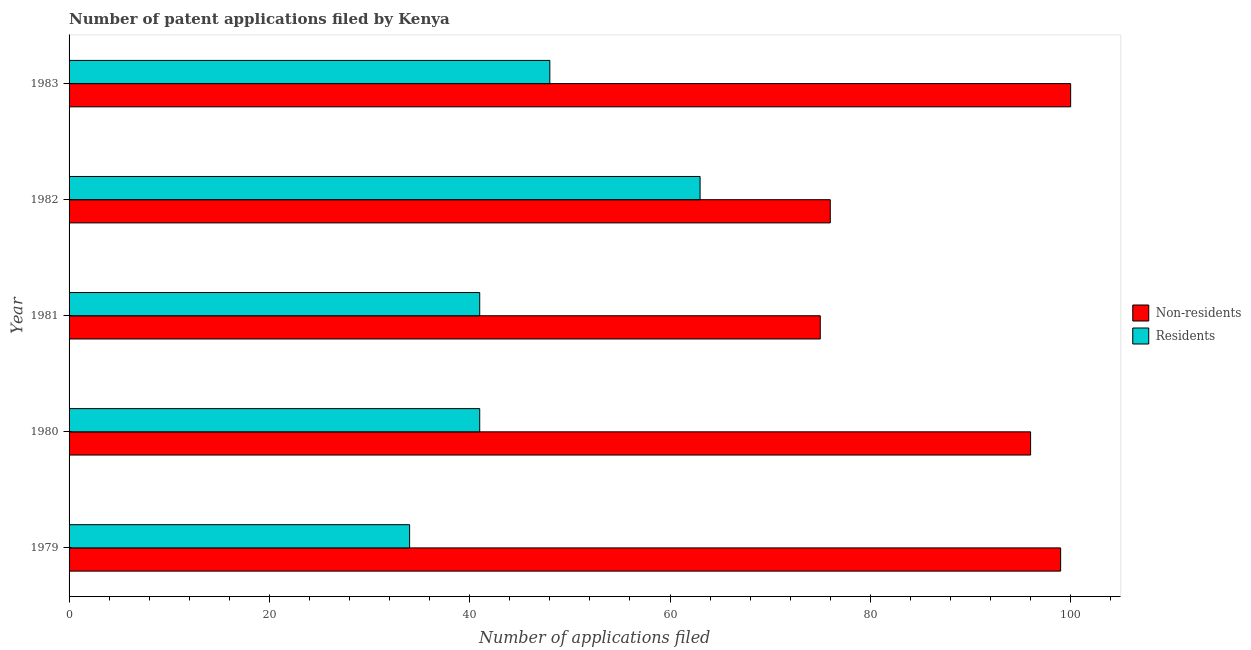How many groups of bars are there?
Keep it short and to the point. 5. Are the number of bars on each tick of the Y-axis equal?
Provide a short and direct response. Yes. How many bars are there on the 1st tick from the top?
Provide a succinct answer. 2. What is the label of the 5th group of bars from the top?
Provide a short and direct response. 1979. In how many cases, is the number of bars for a given year not equal to the number of legend labels?
Provide a succinct answer. 0. What is the number of patent applications by residents in 1983?
Your answer should be compact. 48. Across all years, what is the maximum number of patent applications by non residents?
Give a very brief answer. 100. Across all years, what is the minimum number of patent applications by residents?
Offer a terse response. 34. In which year was the number of patent applications by residents minimum?
Keep it short and to the point. 1979. What is the total number of patent applications by non residents in the graph?
Give a very brief answer. 446. What is the difference between the number of patent applications by non residents in 1981 and that in 1983?
Provide a succinct answer. -25. What is the difference between the number of patent applications by non residents in 1983 and the number of patent applications by residents in 1980?
Ensure brevity in your answer.  59. What is the average number of patent applications by residents per year?
Provide a succinct answer. 45.4. In the year 1981, what is the difference between the number of patent applications by non residents and number of patent applications by residents?
Provide a short and direct response. 34. What is the ratio of the number of patent applications by non residents in 1979 to that in 1982?
Provide a short and direct response. 1.3. Is the number of patent applications by residents in 1980 less than that in 1982?
Provide a succinct answer. Yes. Is the difference between the number of patent applications by non residents in 1980 and 1983 greater than the difference between the number of patent applications by residents in 1980 and 1983?
Your response must be concise. Yes. What is the difference between the highest and the second highest number of patent applications by residents?
Provide a succinct answer. 15. What is the difference between the highest and the lowest number of patent applications by non residents?
Offer a very short reply. 25. What does the 2nd bar from the top in 1980 represents?
Your answer should be very brief. Non-residents. What does the 2nd bar from the bottom in 1980 represents?
Provide a succinct answer. Residents. How many bars are there?
Ensure brevity in your answer.  10. What is the difference between two consecutive major ticks on the X-axis?
Make the answer very short. 20. Are the values on the major ticks of X-axis written in scientific E-notation?
Your answer should be compact. No. Does the graph contain grids?
Offer a very short reply. No. What is the title of the graph?
Provide a short and direct response. Number of patent applications filed by Kenya. Does "current US$" appear as one of the legend labels in the graph?
Offer a very short reply. No. What is the label or title of the X-axis?
Your response must be concise. Number of applications filed. What is the label or title of the Y-axis?
Make the answer very short. Year. What is the Number of applications filed in Residents in 1979?
Give a very brief answer. 34. What is the Number of applications filed in Non-residents in 1980?
Offer a very short reply. 96. What is the Number of applications filed in Non-residents in 1981?
Provide a short and direct response. 75. What is the Number of applications filed in Residents in 1981?
Offer a very short reply. 41. What is the Number of applications filed of Non-residents in 1982?
Offer a terse response. 76. What is the Number of applications filed of Residents in 1982?
Make the answer very short. 63. What is the Number of applications filed in Non-residents in 1983?
Your answer should be very brief. 100. What is the Number of applications filed in Residents in 1983?
Give a very brief answer. 48. Across all years, what is the maximum Number of applications filed of Non-residents?
Ensure brevity in your answer.  100. Across all years, what is the maximum Number of applications filed in Residents?
Offer a very short reply. 63. What is the total Number of applications filed in Non-residents in the graph?
Provide a short and direct response. 446. What is the total Number of applications filed in Residents in the graph?
Provide a short and direct response. 227. What is the difference between the Number of applications filed of Non-residents in 1979 and that in 1980?
Provide a short and direct response. 3. What is the difference between the Number of applications filed of Non-residents in 1979 and that in 1981?
Offer a terse response. 24. What is the difference between the Number of applications filed in Residents in 1979 and that in 1981?
Your response must be concise. -7. What is the difference between the Number of applications filed in Non-residents in 1979 and that in 1983?
Make the answer very short. -1. What is the difference between the Number of applications filed of Non-residents in 1980 and that in 1981?
Keep it short and to the point. 21. What is the difference between the Number of applications filed of Residents in 1980 and that in 1981?
Your answer should be compact. 0. What is the difference between the Number of applications filed in Non-residents in 1980 and that in 1982?
Ensure brevity in your answer.  20. What is the difference between the Number of applications filed in Non-residents in 1980 and that in 1983?
Your response must be concise. -4. What is the difference between the Number of applications filed of Non-residents in 1981 and that in 1982?
Your answer should be very brief. -1. What is the difference between the Number of applications filed in Residents in 1981 and that in 1982?
Offer a terse response. -22. What is the difference between the Number of applications filed in Non-residents in 1981 and that in 1983?
Make the answer very short. -25. What is the difference between the Number of applications filed of Residents in 1981 and that in 1983?
Give a very brief answer. -7. What is the difference between the Number of applications filed in Non-residents in 1982 and that in 1983?
Ensure brevity in your answer.  -24. What is the difference between the Number of applications filed of Residents in 1982 and that in 1983?
Your answer should be compact. 15. What is the difference between the Number of applications filed of Non-residents in 1979 and the Number of applications filed of Residents in 1980?
Provide a short and direct response. 58. What is the difference between the Number of applications filed in Non-residents in 1979 and the Number of applications filed in Residents in 1983?
Make the answer very short. 51. What is the difference between the Number of applications filed of Non-residents in 1980 and the Number of applications filed of Residents in 1981?
Provide a succinct answer. 55. What is the difference between the Number of applications filed in Non-residents in 1980 and the Number of applications filed in Residents in 1983?
Offer a terse response. 48. What is the difference between the Number of applications filed of Non-residents in 1981 and the Number of applications filed of Residents in 1983?
Your response must be concise. 27. What is the difference between the Number of applications filed of Non-residents in 1982 and the Number of applications filed of Residents in 1983?
Provide a short and direct response. 28. What is the average Number of applications filed in Non-residents per year?
Offer a terse response. 89.2. What is the average Number of applications filed in Residents per year?
Keep it short and to the point. 45.4. In the year 1981, what is the difference between the Number of applications filed of Non-residents and Number of applications filed of Residents?
Make the answer very short. 34. In the year 1983, what is the difference between the Number of applications filed in Non-residents and Number of applications filed in Residents?
Your answer should be compact. 52. What is the ratio of the Number of applications filed in Non-residents in 1979 to that in 1980?
Offer a terse response. 1.03. What is the ratio of the Number of applications filed of Residents in 1979 to that in 1980?
Your answer should be compact. 0.83. What is the ratio of the Number of applications filed of Non-residents in 1979 to that in 1981?
Your response must be concise. 1.32. What is the ratio of the Number of applications filed of Residents in 1979 to that in 1981?
Offer a terse response. 0.83. What is the ratio of the Number of applications filed of Non-residents in 1979 to that in 1982?
Your answer should be compact. 1.3. What is the ratio of the Number of applications filed in Residents in 1979 to that in 1982?
Keep it short and to the point. 0.54. What is the ratio of the Number of applications filed in Non-residents in 1979 to that in 1983?
Provide a short and direct response. 0.99. What is the ratio of the Number of applications filed of Residents in 1979 to that in 1983?
Offer a terse response. 0.71. What is the ratio of the Number of applications filed in Non-residents in 1980 to that in 1981?
Offer a very short reply. 1.28. What is the ratio of the Number of applications filed in Non-residents in 1980 to that in 1982?
Your answer should be very brief. 1.26. What is the ratio of the Number of applications filed in Residents in 1980 to that in 1982?
Provide a short and direct response. 0.65. What is the ratio of the Number of applications filed in Non-residents in 1980 to that in 1983?
Keep it short and to the point. 0.96. What is the ratio of the Number of applications filed of Residents in 1980 to that in 1983?
Provide a short and direct response. 0.85. What is the ratio of the Number of applications filed in Residents in 1981 to that in 1982?
Offer a very short reply. 0.65. What is the ratio of the Number of applications filed in Non-residents in 1981 to that in 1983?
Offer a terse response. 0.75. What is the ratio of the Number of applications filed in Residents in 1981 to that in 1983?
Offer a terse response. 0.85. What is the ratio of the Number of applications filed in Non-residents in 1982 to that in 1983?
Offer a very short reply. 0.76. What is the ratio of the Number of applications filed in Residents in 1982 to that in 1983?
Your answer should be very brief. 1.31. What is the difference between the highest and the second highest Number of applications filed of Residents?
Offer a terse response. 15. What is the difference between the highest and the lowest Number of applications filed of Non-residents?
Make the answer very short. 25. 